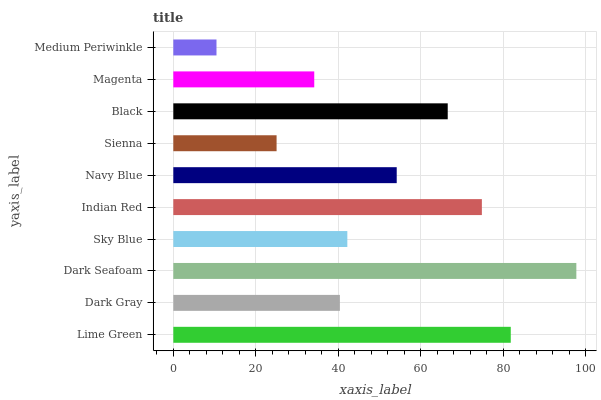Is Medium Periwinkle the minimum?
Answer yes or no. Yes. Is Dark Seafoam the maximum?
Answer yes or no. Yes. Is Dark Gray the minimum?
Answer yes or no. No. Is Dark Gray the maximum?
Answer yes or no. No. Is Lime Green greater than Dark Gray?
Answer yes or no. Yes. Is Dark Gray less than Lime Green?
Answer yes or no. Yes. Is Dark Gray greater than Lime Green?
Answer yes or no. No. Is Lime Green less than Dark Gray?
Answer yes or no. No. Is Navy Blue the high median?
Answer yes or no. Yes. Is Sky Blue the low median?
Answer yes or no. Yes. Is Indian Red the high median?
Answer yes or no. No. Is Dark Seafoam the low median?
Answer yes or no. No. 